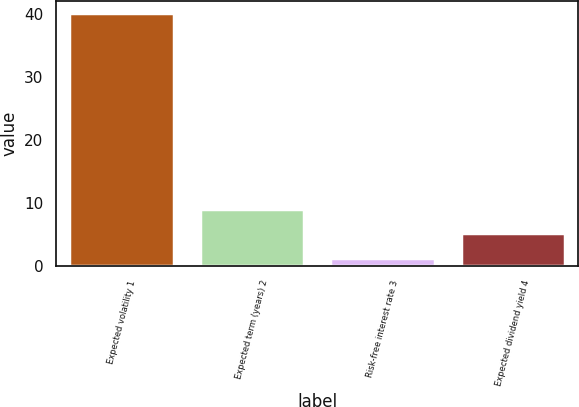<chart> <loc_0><loc_0><loc_500><loc_500><bar_chart><fcel>Expected volatility 1<fcel>Expected term (years) 2<fcel>Risk-free interest rate 3<fcel>Expected dividend yield 4<nl><fcel>40.2<fcel>9.08<fcel>1.3<fcel>5.19<nl></chart> 